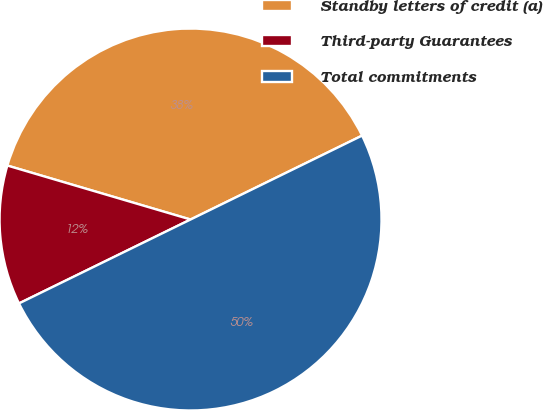Convert chart. <chart><loc_0><loc_0><loc_500><loc_500><pie_chart><fcel>Standby letters of credit (a)<fcel>Third-party Guarantees<fcel>Total commitments<nl><fcel>38.2%<fcel>11.8%<fcel>50.0%<nl></chart> 